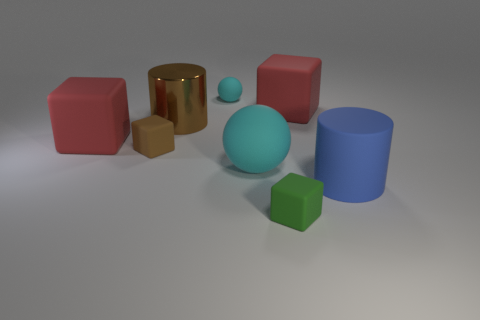Could you describe the spatial arrangement of the objects? Certainly! The objects are arranged in a scattered manner across a flat surface. On the left, there is a sizable red cube, a small gold cube, and a blue cylinder. Centered is a large aqua sphere, and to the right, a small green cube and a red cube are in the foreground with a small matte cyan sphere in the back. 